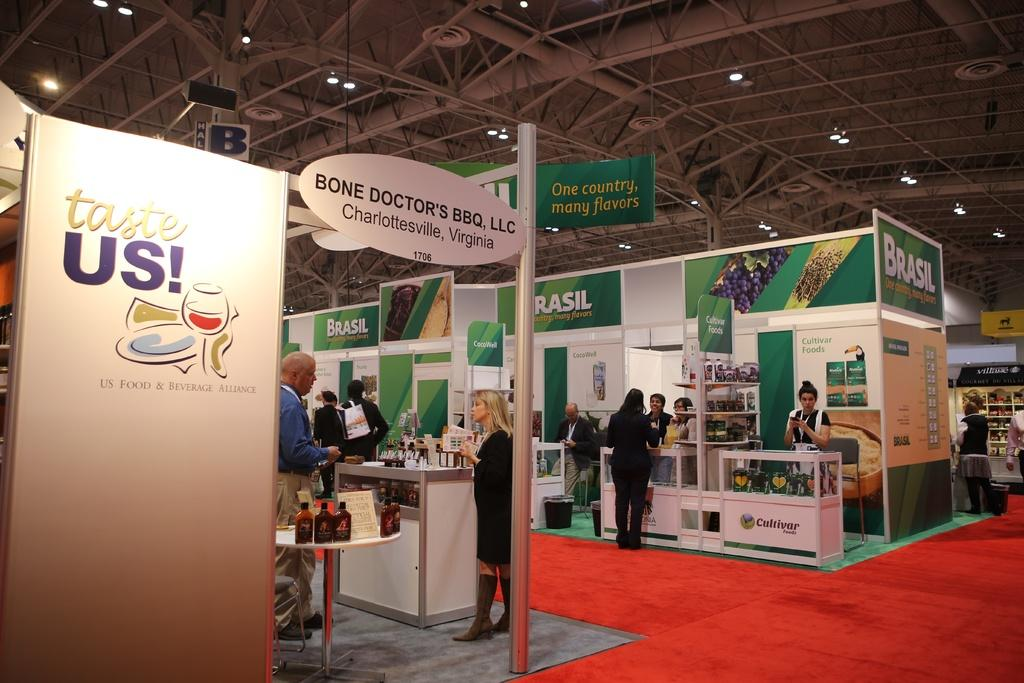Provide a one-sentence caption for the provided image. People at a convention with a sign that says "Taste us!". 